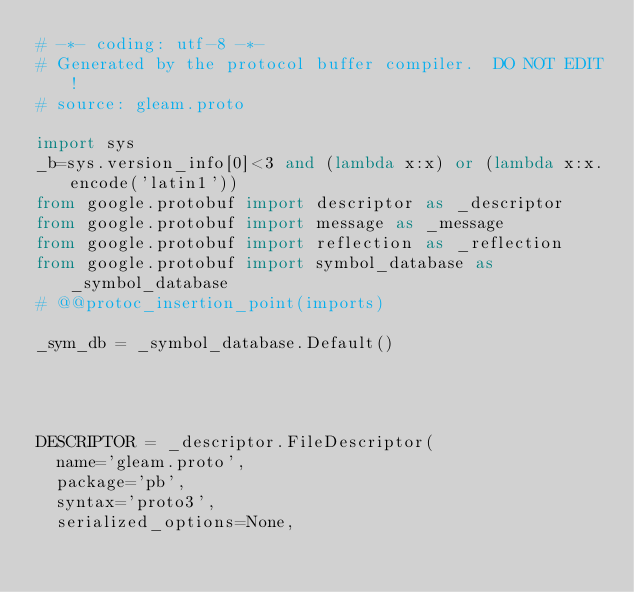<code> <loc_0><loc_0><loc_500><loc_500><_Python_># -*- coding: utf-8 -*-
# Generated by the protocol buffer compiler.  DO NOT EDIT!
# source: gleam.proto

import sys
_b=sys.version_info[0]<3 and (lambda x:x) or (lambda x:x.encode('latin1'))
from google.protobuf import descriptor as _descriptor
from google.protobuf import message as _message
from google.protobuf import reflection as _reflection
from google.protobuf import symbol_database as _symbol_database
# @@protoc_insertion_point(imports)

_sym_db = _symbol_database.Default()




DESCRIPTOR = _descriptor.FileDescriptor(
  name='gleam.proto',
  package='pb',
  syntax='proto3',
  serialized_options=None,</code> 